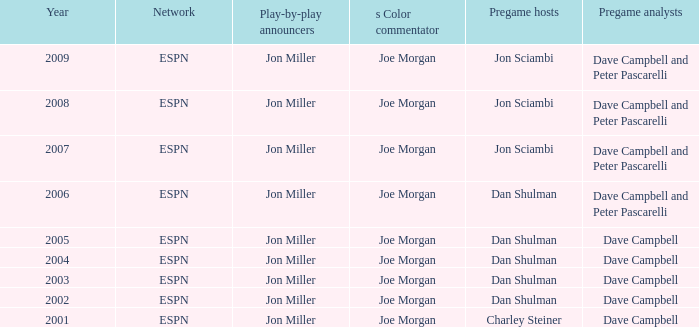Who is the pregame host when the pregame analysts is  Dave Campbell and the year is 2001? Charley Steiner. 